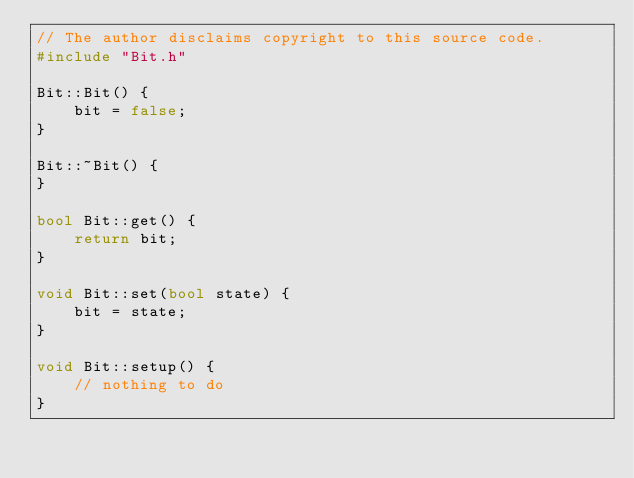<code> <loc_0><loc_0><loc_500><loc_500><_C++_>// The author disclaims copyright to this source code.
#include "Bit.h"

Bit::Bit() {
	bit = false;
}

Bit::~Bit() {
}

bool Bit::get() {
	return bit;
}

void Bit::set(bool state) {
	bit = state;
}

void Bit::setup() {
	// nothing to do
}
</code> 